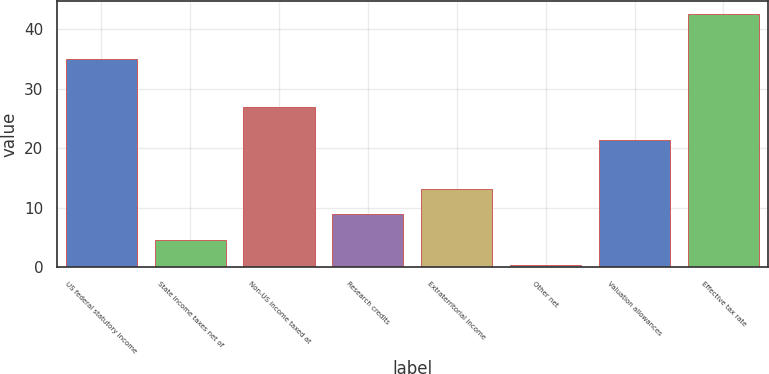<chart> <loc_0><loc_0><loc_500><loc_500><bar_chart><fcel>US federal statutory income<fcel>State income taxes net of<fcel>Non-US income taxed at<fcel>Research credits<fcel>Extraterritorial income<fcel>Other net<fcel>Valuation allowances<fcel>Effective tax rate<nl><fcel>35<fcel>4.62<fcel>26.9<fcel>8.84<fcel>13.06<fcel>0.4<fcel>21.4<fcel>42.6<nl></chart> 